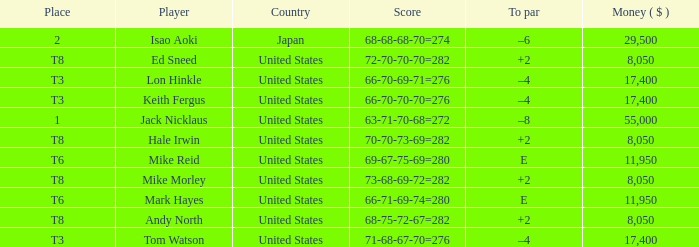What to par is located in the united states and has the player by the name of hale irwin? 2.0. 